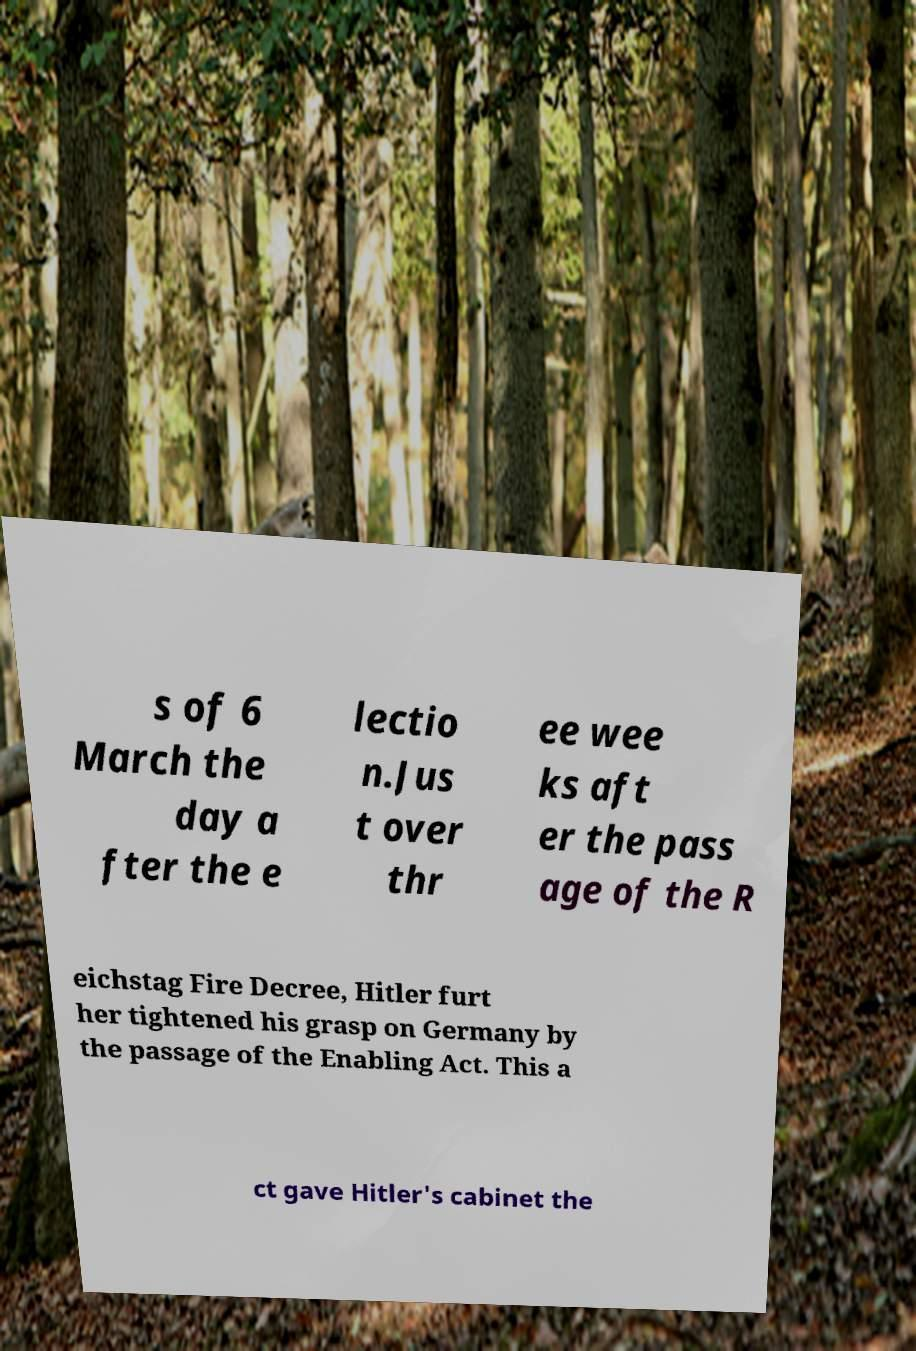Please read and relay the text visible in this image. What does it say? s of 6 March the day a fter the e lectio n.Jus t over thr ee wee ks aft er the pass age of the R eichstag Fire Decree, Hitler furt her tightened his grasp on Germany by the passage of the Enabling Act. This a ct gave Hitler's cabinet the 